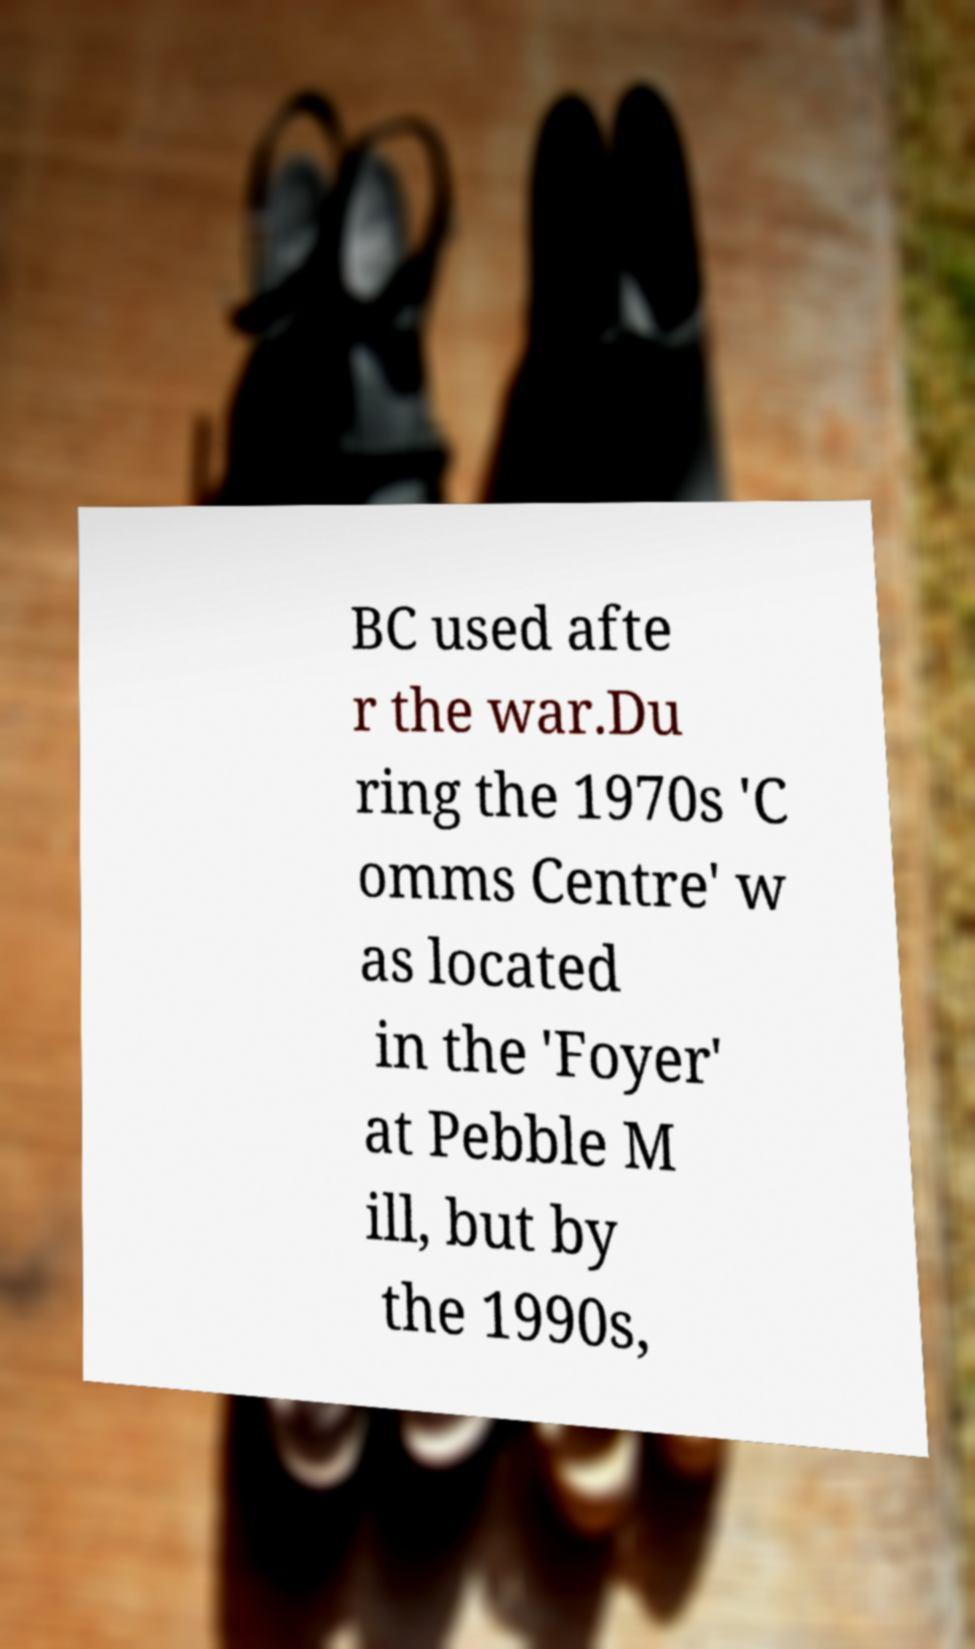Can you read and provide the text displayed in the image?This photo seems to have some interesting text. Can you extract and type it out for me? BC used afte r the war.Du ring the 1970s 'C omms Centre' w as located in the 'Foyer' at Pebble M ill, but by the 1990s, 